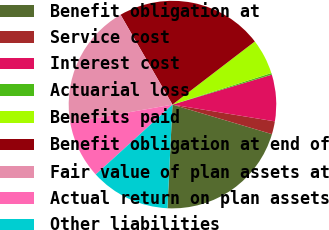<chart> <loc_0><loc_0><loc_500><loc_500><pie_chart><fcel>Benefit obligation at<fcel>Service cost<fcel>Interest cost<fcel>Actuarial loss<fcel>Benefits paid<fcel>Benefit obligation at end of<fcel>Fair value of plan assets at<fcel>Actual return on plan assets<fcel>Other liabilities<nl><fcel>21.18%<fcel>2.01%<fcel>7.24%<fcel>0.26%<fcel>5.49%<fcel>22.93%<fcel>19.44%<fcel>8.98%<fcel>12.47%<nl></chart> 